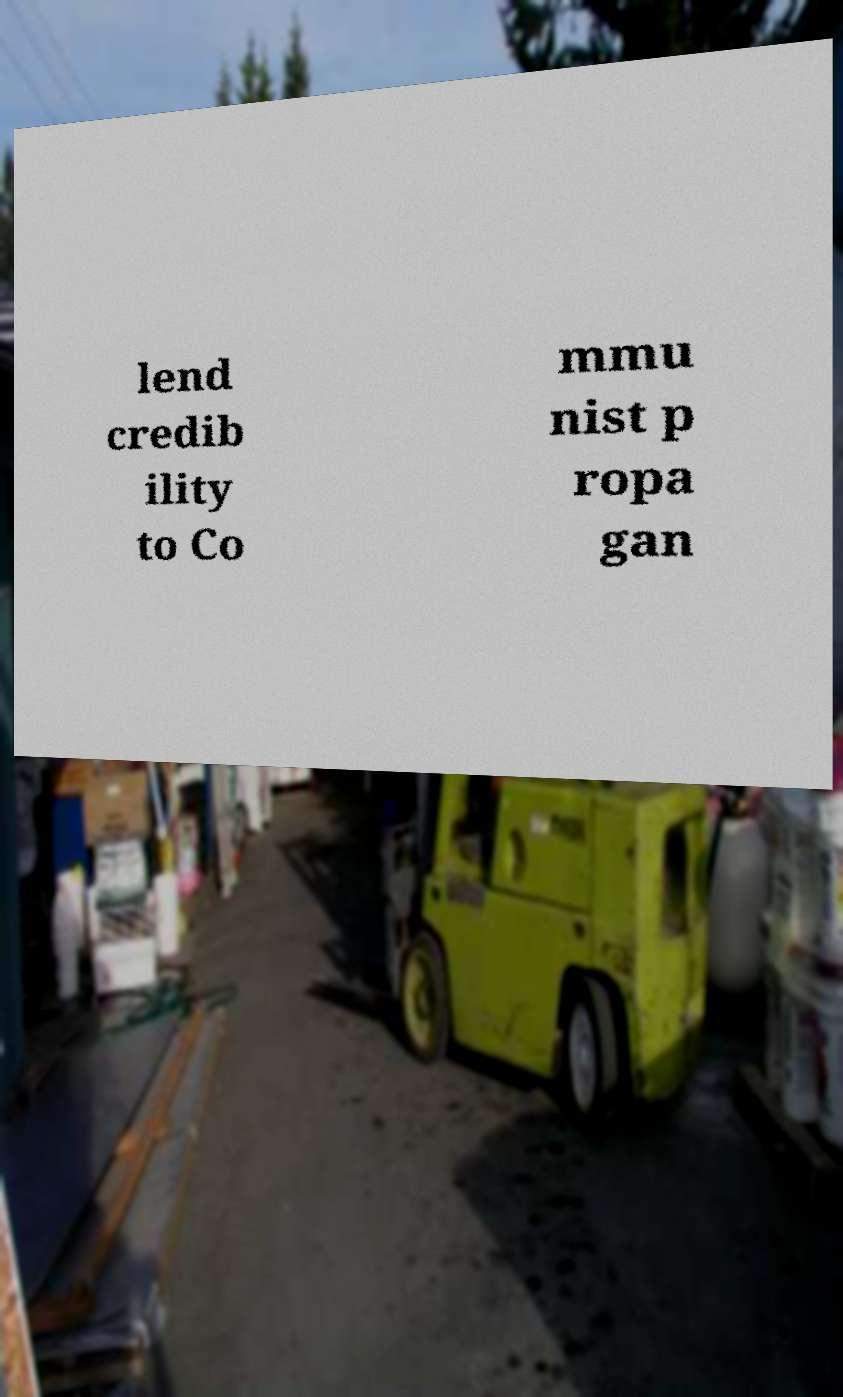Could you assist in decoding the text presented in this image and type it out clearly? lend credib ility to Co mmu nist p ropa gan 